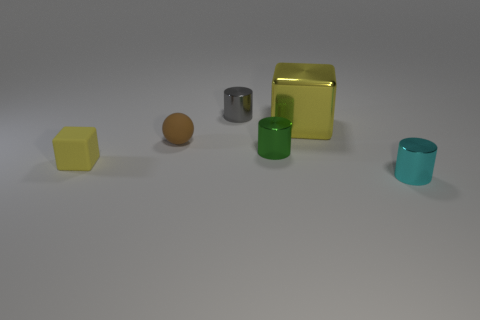There is a small matte ball; are there any tiny cylinders behind it?
Offer a very short reply. Yes. There is a rubber cube; does it have the same size as the yellow cube that is behind the tiny green cylinder?
Your answer should be compact. No. How many other objects are the same material as the cyan thing?
Provide a succinct answer. 3. What is the shape of the thing that is both in front of the tiny green shiny cylinder and right of the small cube?
Ensure brevity in your answer.  Cylinder. Is the size of the metal cylinder behind the small brown rubber sphere the same as the brown matte ball that is in front of the gray cylinder?
Provide a succinct answer. Yes. What is the shape of the gray thing that is made of the same material as the big yellow cube?
Your answer should be compact. Cylinder. Is there any other thing that is the same shape as the small gray thing?
Give a very brief answer. Yes. There is a tiny object on the left side of the matte object that is behind the block left of the gray cylinder; what color is it?
Provide a short and direct response. Yellow. Are there fewer large yellow metal things to the left of the small sphere than brown objects that are in front of the gray metallic cylinder?
Ensure brevity in your answer.  Yes. Is the shape of the small cyan thing the same as the yellow shiny thing?
Make the answer very short. No. 